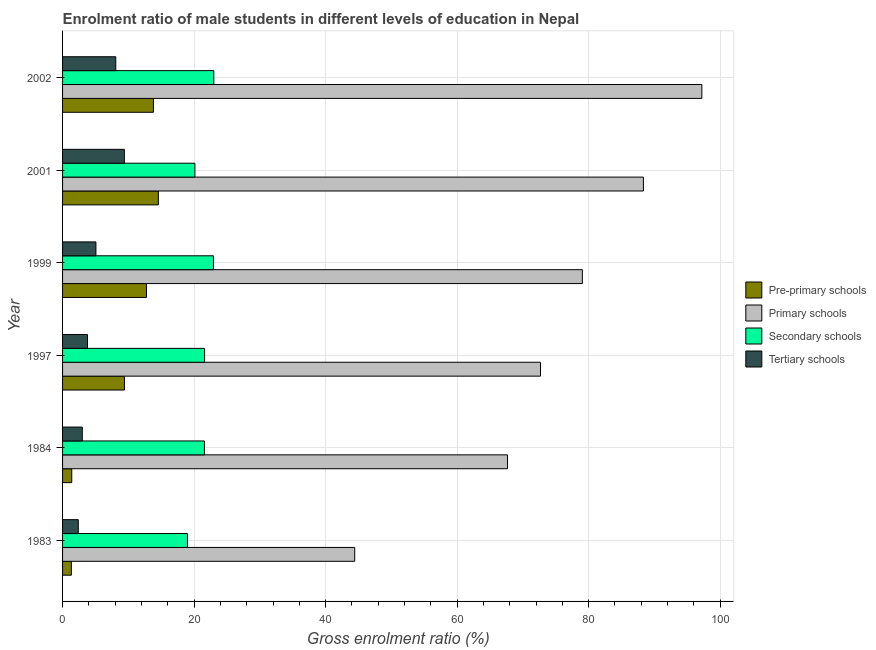How many different coloured bars are there?
Make the answer very short. 4. Are the number of bars on each tick of the Y-axis equal?
Ensure brevity in your answer.  Yes. How many bars are there on the 3rd tick from the top?
Offer a very short reply. 4. In how many cases, is the number of bars for a given year not equal to the number of legend labels?
Keep it short and to the point. 0. What is the gross enrolment ratio(female) in primary schools in 2001?
Give a very brief answer. 88.33. Across all years, what is the maximum gross enrolment ratio(female) in primary schools?
Ensure brevity in your answer.  97.22. Across all years, what is the minimum gross enrolment ratio(female) in pre-primary schools?
Provide a succinct answer. 1.33. In which year was the gross enrolment ratio(female) in pre-primary schools maximum?
Your response must be concise. 2001. What is the total gross enrolment ratio(female) in tertiary schools in the graph?
Offer a terse response. 31.73. What is the difference between the gross enrolment ratio(female) in pre-primary schools in 1997 and that in 2001?
Your answer should be very brief. -5.16. What is the difference between the gross enrolment ratio(female) in secondary schools in 2002 and the gross enrolment ratio(female) in pre-primary schools in 1983?
Keep it short and to the point. 21.67. What is the average gross enrolment ratio(female) in tertiary schools per year?
Keep it short and to the point. 5.29. In the year 2001, what is the difference between the gross enrolment ratio(female) in secondary schools and gross enrolment ratio(female) in primary schools?
Give a very brief answer. -68.2. What is the ratio of the gross enrolment ratio(female) in secondary schools in 1983 to that in 1999?
Your answer should be very brief. 0.83. What is the difference between the highest and the second highest gross enrolment ratio(female) in tertiary schools?
Offer a terse response. 1.3. What is the difference between the highest and the lowest gross enrolment ratio(female) in secondary schools?
Your response must be concise. 4.01. Is the sum of the gross enrolment ratio(female) in pre-primary schools in 1984 and 1997 greater than the maximum gross enrolment ratio(female) in tertiary schools across all years?
Your answer should be very brief. Yes. What does the 1st bar from the top in 1983 represents?
Ensure brevity in your answer.  Tertiary schools. What does the 1st bar from the bottom in 1997 represents?
Keep it short and to the point. Pre-primary schools. Are the values on the major ticks of X-axis written in scientific E-notation?
Offer a terse response. No. Does the graph contain any zero values?
Your answer should be very brief. No. What is the title of the graph?
Your answer should be compact. Enrolment ratio of male students in different levels of education in Nepal. What is the label or title of the X-axis?
Give a very brief answer. Gross enrolment ratio (%). What is the label or title of the Y-axis?
Give a very brief answer. Year. What is the Gross enrolment ratio (%) of Pre-primary schools in 1983?
Offer a very short reply. 1.33. What is the Gross enrolment ratio (%) of Primary schools in 1983?
Offer a very short reply. 44.42. What is the Gross enrolment ratio (%) in Secondary schools in 1983?
Provide a short and direct response. 18.99. What is the Gross enrolment ratio (%) of Tertiary schools in 1983?
Offer a very short reply. 2.39. What is the Gross enrolment ratio (%) of Pre-primary schools in 1984?
Your response must be concise. 1.4. What is the Gross enrolment ratio (%) of Primary schools in 1984?
Offer a terse response. 67.66. What is the Gross enrolment ratio (%) of Secondary schools in 1984?
Provide a succinct answer. 21.57. What is the Gross enrolment ratio (%) in Tertiary schools in 1984?
Offer a terse response. 3. What is the Gross enrolment ratio (%) in Pre-primary schools in 1997?
Give a very brief answer. 9.41. What is the Gross enrolment ratio (%) in Primary schools in 1997?
Offer a very short reply. 72.68. What is the Gross enrolment ratio (%) in Secondary schools in 1997?
Your response must be concise. 21.6. What is the Gross enrolment ratio (%) of Tertiary schools in 1997?
Your answer should be very brief. 3.79. What is the Gross enrolment ratio (%) of Pre-primary schools in 1999?
Offer a very short reply. 12.76. What is the Gross enrolment ratio (%) in Primary schools in 1999?
Your response must be concise. 79.04. What is the Gross enrolment ratio (%) in Secondary schools in 1999?
Offer a terse response. 22.95. What is the Gross enrolment ratio (%) in Tertiary schools in 1999?
Your answer should be compact. 5.07. What is the Gross enrolment ratio (%) of Pre-primary schools in 2001?
Your response must be concise. 14.57. What is the Gross enrolment ratio (%) of Primary schools in 2001?
Offer a very short reply. 88.33. What is the Gross enrolment ratio (%) in Secondary schools in 2001?
Ensure brevity in your answer.  20.13. What is the Gross enrolment ratio (%) of Tertiary schools in 2001?
Keep it short and to the point. 9.39. What is the Gross enrolment ratio (%) of Pre-primary schools in 2002?
Your answer should be very brief. 13.82. What is the Gross enrolment ratio (%) in Primary schools in 2002?
Provide a short and direct response. 97.22. What is the Gross enrolment ratio (%) in Secondary schools in 2002?
Make the answer very short. 23. What is the Gross enrolment ratio (%) in Tertiary schools in 2002?
Your answer should be compact. 8.09. Across all years, what is the maximum Gross enrolment ratio (%) in Pre-primary schools?
Ensure brevity in your answer.  14.57. Across all years, what is the maximum Gross enrolment ratio (%) of Primary schools?
Offer a very short reply. 97.22. Across all years, what is the maximum Gross enrolment ratio (%) in Secondary schools?
Your response must be concise. 23. Across all years, what is the maximum Gross enrolment ratio (%) in Tertiary schools?
Offer a terse response. 9.39. Across all years, what is the minimum Gross enrolment ratio (%) in Pre-primary schools?
Make the answer very short. 1.33. Across all years, what is the minimum Gross enrolment ratio (%) of Primary schools?
Keep it short and to the point. 44.42. Across all years, what is the minimum Gross enrolment ratio (%) of Secondary schools?
Your answer should be very brief. 18.99. Across all years, what is the minimum Gross enrolment ratio (%) of Tertiary schools?
Give a very brief answer. 2.39. What is the total Gross enrolment ratio (%) of Pre-primary schools in the graph?
Give a very brief answer. 53.29. What is the total Gross enrolment ratio (%) in Primary schools in the graph?
Ensure brevity in your answer.  449.36. What is the total Gross enrolment ratio (%) of Secondary schools in the graph?
Offer a very short reply. 128.24. What is the total Gross enrolment ratio (%) in Tertiary schools in the graph?
Offer a very short reply. 31.73. What is the difference between the Gross enrolment ratio (%) in Pre-primary schools in 1983 and that in 1984?
Make the answer very short. -0.06. What is the difference between the Gross enrolment ratio (%) in Primary schools in 1983 and that in 1984?
Make the answer very short. -23.24. What is the difference between the Gross enrolment ratio (%) in Secondary schools in 1983 and that in 1984?
Your response must be concise. -2.58. What is the difference between the Gross enrolment ratio (%) in Tertiary schools in 1983 and that in 1984?
Give a very brief answer. -0.61. What is the difference between the Gross enrolment ratio (%) in Pre-primary schools in 1983 and that in 1997?
Offer a very short reply. -8.07. What is the difference between the Gross enrolment ratio (%) in Primary schools in 1983 and that in 1997?
Your response must be concise. -28.25. What is the difference between the Gross enrolment ratio (%) in Secondary schools in 1983 and that in 1997?
Your answer should be compact. -2.6. What is the difference between the Gross enrolment ratio (%) of Tertiary schools in 1983 and that in 1997?
Offer a very short reply. -1.4. What is the difference between the Gross enrolment ratio (%) of Pre-primary schools in 1983 and that in 1999?
Provide a succinct answer. -11.43. What is the difference between the Gross enrolment ratio (%) of Primary schools in 1983 and that in 1999?
Your answer should be compact. -34.62. What is the difference between the Gross enrolment ratio (%) of Secondary schools in 1983 and that in 1999?
Make the answer very short. -3.96. What is the difference between the Gross enrolment ratio (%) in Tertiary schools in 1983 and that in 1999?
Offer a terse response. -2.68. What is the difference between the Gross enrolment ratio (%) in Pre-primary schools in 1983 and that in 2001?
Offer a terse response. -13.23. What is the difference between the Gross enrolment ratio (%) in Primary schools in 1983 and that in 2001?
Your answer should be very brief. -43.9. What is the difference between the Gross enrolment ratio (%) in Secondary schools in 1983 and that in 2001?
Your answer should be compact. -1.13. What is the difference between the Gross enrolment ratio (%) of Tertiary schools in 1983 and that in 2001?
Ensure brevity in your answer.  -7. What is the difference between the Gross enrolment ratio (%) in Pre-primary schools in 1983 and that in 2002?
Give a very brief answer. -12.49. What is the difference between the Gross enrolment ratio (%) in Primary schools in 1983 and that in 2002?
Your response must be concise. -52.79. What is the difference between the Gross enrolment ratio (%) in Secondary schools in 1983 and that in 2002?
Make the answer very short. -4.01. What is the difference between the Gross enrolment ratio (%) of Tertiary schools in 1983 and that in 2002?
Give a very brief answer. -5.7. What is the difference between the Gross enrolment ratio (%) in Pre-primary schools in 1984 and that in 1997?
Your response must be concise. -8.01. What is the difference between the Gross enrolment ratio (%) in Primary schools in 1984 and that in 1997?
Provide a short and direct response. -5.01. What is the difference between the Gross enrolment ratio (%) of Secondary schools in 1984 and that in 1997?
Provide a short and direct response. -0.03. What is the difference between the Gross enrolment ratio (%) of Tertiary schools in 1984 and that in 1997?
Offer a very short reply. -0.79. What is the difference between the Gross enrolment ratio (%) of Pre-primary schools in 1984 and that in 1999?
Ensure brevity in your answer.  -11.37. What is the difference between the Gross enrolment ratio (%) in Primary schools in 1984 and that in 1999?
Your answer should be very brief. -11.38. What is the difference between the Gross enrolment ratio (%) of Secondary schools in 1984 and that in 1999?
Ensure brevity in your answer.  -1.38. What is the difference between the Gross enrolment ratio (%) of Tertiary schools in 1984 and that in 1999?
Keep it short and to the point. -2.07. What is the difference between the Gross enrolment ratio (%) of Pre-primary schools in 1984 and that in 2001?
Offer a terse response. -13.17. What is the difference between the Gross enrolment ratio (%) of Primary schools in 1984 and that in 2001?
Keep it short and to the point. -20.66. What is the difference between the Gross enrolment ratio (%) in Secondary schools in 1984 and that in 2001?
Give a very brief answer. 1.45. What is the difference between the Gross enrolment ratio (%) in Tertiary schools in 1984 and that in 2001?
Give a very brief answer. -6.4. What is the difference between the Gross enrolment ratio (%) of Pre-primary schools in 1984 and that in 2002?
Give a very brief answer. -12.42. What is the difference between the Gross enrolment ratio (%) in Primary schools in 1984 and that in 2002?
Provide a short and direct response. -29.55. What is the difference between the Gross enrolment ratio (%) in Secondary schools in 1984 and that in 2002?
Your answer should be compact. -1.43. What is the difference between the Gross enrolment ratio (%) in Tertiary schools in 1984 and that in 2002?
Provide a short and direct response. -5.09. What is the difference between the Gross enrolment ratio (%) of Pre-primary schools in 1997 and that in 1999?
Make the answer very short. -3.36. What is the difference between the Gross enrolment ratio (%) in Primary schools in 1997 and that in 1999?
Make the answer very short. -6.37. What is the difference between the Gross enrolment ratio (%) of Secondary schools in 1997 and that in 1999?
Provide a short and direct response. -1.35. What is the difference between the Gross enrolment ratio (%) of Tertiary schools in 1997 and that in 1999?
Offer a terse response. -1.28. What is the difference between the Gross enrolment ratio (%) in Pre-primary schools in 1997 and that in 2001?
Make the answer very short. -5.16. What is the difference between the Gross enrolment ratio (%) in Primary schools in 1997 and that in 2001?
Make the answer very short. -15.65. What is the difference between the Gross enrolment ratio (%) in Secondary schools in 1997 and that in 2001?
Your answer should be compact. 1.47. What is the difference between the Gross enrolment ratio (%) in Tertiary schools in 1997 and that in 2001?
Provide a succinct answer. -5.61. What is the difference between the Gross enrolment ratio (%) of Pre-primary schools in 1997 and that in 2002?
Make the answer very short. -4.41. What is the difference between the Gross enrolment ratio (%) of Primary schools in 1997 and that in 2002?
Give a very brief answer. -24.54. What is the difference between the Gross enrolment ratio (%) in Secondary schools in 1997 and that in 2002?
Provide a short and direct response. -1.4. What is the difference between the Gross enrolment ratio (%) of Tertiary schools in 1997 and that in 2002?
Offer a terse response. -4.3. What is the difference between the Gross enrolment ratio (%) in Pre-primary schools in 1999 and that in 2001?
Ensure brevity in your answer.  -1.8. What is the difference between the Gross enrolment ratio (%) of Primary schools in 1999 and that in 2001?
Keep it short and to the point. -9.28. What is the difference between the Gross enrolment ratio (%) in Secondary schools in 1999 and that in 2001?
Offer a very short reply. 2.82. What is the difference between the Gross enrolment ratio (%) in Tertiary schools in 1999 and that in 2001?
Ensure brevity in your answer.  -4.32. What is the difference between the Gross enrolment ratio (%) of Pre-primary schools in 1999 and that in 2002?
Your answer should be compact. -1.06. What is the difference between the Gross enrolment ratio (%) in Primary schools in 1999 and that in 2002?
Offer a terse response. -18.17. What is the difference between the Gross enrolment ratio (%) of Secondary schools in 1999 and that in 2002?
Your answer should be very brief. -0.05. What is the difference between the Gross enrolment ratio (%) in Tertiary schools in 1999 and that in 2002?
Keep it short and to the point. -3.02. What is the difference between the Gross enrolment ratio (%) of Pre-primary schools in 2001 and that in 2002?
Offer a very short reply. 0.75. What is the difference between the Gross enrolment ratio (%) in Primary schools in 2001 and that in 2002?
Offer a terse response. -8.89. What is the difference between the Gross enrolment ratio (%) of Secondary schools in 2001 and that in 2002?
Your answer should be compact. -2.87. What is the difference between the Gross enrolment ratio (%) in Tertiary schools in 2001 and that in 2002?
Offer a terse response. 1.3. What is the difference between the Gross enrolment ratio (%) in Pre-primary schools in 1983 and the Gross enrolment ratio (%) in Primary schools in 1984?
Your response must be concise. -66.33. What is the difference between the Gross enrolment ratio (%) in Pre-primary schools in 1983 and the Gross enrolment ratio (%) in Secondary schools in 1984?
Keep it short and to the point. -20.24. What is the difference between the Gross enrolment ratio (%) in Pre-primary schools in 1983 and the Gross enrolment ratio (%) in Tertiary schools in 1984?
Give a very brief answer. -1.66. What is the difference between the Gross enrolment ratio (%) of Primary schools in 1983 and the Gross enrolment ratio (%) of Secondary schools in 1984?
Make the answer very short. 22.85. What is the difference between the Gross enrolment ratio (%) in Primary schools in 1983 and the Gross enrolment ratio (%) in Tertiary schools in 1984?
Provide a succinct answer. 41.43. What is the difference between the Gross enrolment ratio (%) of Secondary schools in 1983 and the Gross enrolment ratio (%) of Tertiary schools in 1984?
Your answer should be very brief. 15.99. What is the difference between the Gross enrolment ratio (%) in Pre-primary schools in 1983 and the Gross enrolment ratio (%) in Primary schools in 1997?
Make the answer very short. -71.34. What is the difference between the Gross enrolment ratio (%) in Pre-primary schools in 1983 and the Gross enrolment ratio (%) in Secondary schools in 1997?
Offer a very short reply. -20.26. What is the difference between the Gross enrolment ratio (%) in Pre-primary schools in 1983 and the Gross enrolment ratio (%) in Tertiary schools in 1997?
Your response must be concise. -2.45. What is the difference between the Gross enrolment ratio (%) of Primary schools in 1983 and the Gross enrolment ratio (%) of Secondary schools in 1997?
Make the answer very short. 22.83. What is the difference between the Gross enrolment ratio (%) in Primary schools in 1983 and the Gross enrolment ratio (%) in Tertiary schools in 1997?
Your answer should be compact. 40.64. What is the difference between the Gross enrolment ratio (%) of Secondary schools in 1983 and the Gross enrolment ratio (%) of Tertiary schools in 1997?
Offer a very short reply. 15.21. What is the difference between the Gross enrolment ratio (%) in Pre-primary schools in 1983 and the Gross enrolment ratio (%) in Primary schools in 1999?
Give a very brief answer. -77.71. What is the difference between the Gross enrolment ratio (%) in Pre-primary schools in 1983 and the Gross enrolment ratio (%) in Secondary schools in 1999?
Keep it short and to the point. -21.61. What is the difference between the Gross enrolment ratio (%) of Pre-primary schools in 1983 and the Gross enrolment ratio (%) of Tertiary schools in 1999?
Your answer should be very brief. -3.74. What is the difference between the Gross enrolment ratio (%) of Primary schools in 1983 and the Gross enrolment ratio (%) of Secondary schools in 1999?
Your answer should be very brief. 21.48. What is the difference between the Gross enrolment ratio (%) in Primary schools in 1983 and the Gross enrolment ratio (%) in Tertiary schools in 1999?
Offer a terse response. 39.35. What is the difference between the Gross enrolment ratio (%) in Secondary schools in 1983 and the Gross enrolment ratio (%) in Tertiary schools in 1999?
Keep it short and to the point. 13.92. What is the difference between the Gross enrolment ratio (%) in Pre-primary schools in 1983 and the Gross enrolment ratio (%) in Primary schools in 2001?
Ensure brevity in your answer.  -86.99. What is the difference between the Gross enrolment ratio (%) of Pre-primary schools in 1983 and the Gross enrolment ratio (%) of Secondary schools in 2001?
Offer a very short reply. -18.79. What is the difference between the Gross enrolment ratio (%) of Pre-primary schools in 1983 and the Gross enrolment ratio (%) of Tertiary schools in 2001?
Your response must be concise. -8.06. What is the difference between the Gross enrolment ratio (%) in Primary schools in 1983 and the Gross enrolment ratio (%) in Secondary schools in 2001?
Keep it short and to the point. 24.3. What is the difference between the Gross enrolment ratio (%) of Primary schools in 1983 and the Gross enrolment ratio (%) of Tertiary schools in 2001?
Your response must be concise. 35.03. What is the difference between the Gross enrolment ratio (%) in Secondary schools in 1983 and the Gross enrolment ratio (%) in Tertiary schools in 2001?
Give a very brief answer. 9.6. What is the difference between the Gross enrolment ratio (%) of Pre-primary schools in 1983 and the Gross enrolment ratio (%) of Primary schools in 2002?
Make the answer very short. -95.88. What is the difference between the Gross enrolment ratio (%) of Pre-primary schools in 1983 and the Gross enrolment ratio (%) of Secondary schools in 2002?
Ensure brevity in your answer.  -21.67. What is the difference between the Gross enrolment ratio (%) in Pre-primary schools in 1983 and the Gross enrolment ratio (%) in Tertiary schools in 2002?
Your answer should be very brief. -6.76. What is the difference between the Gross enrolment ratio (%) of Primary schools in 1983 and the Gross enrolment ratio (%) of Secondary schools in 2002?
Your answer should be very brief. 21.42. What is the difference between the Gross enrolment ratio (%) of Primary schools in 1983 and the Gross enrolment ratio (%) of Tertiary schools in 2002?
Offer a very short reply. 36.33. What is the difference between the Gross enrolment ratio (%) in Secondary schools in 1983 and the Gross enrolment ratio (%) in Tertiary schools in 2002?
Offer a terse response. 10.9. What is the difference between the Gross enrolment ratio (%) in Pre-primary schools in 1984 and the Gross enrolment ratio (%) in Primary schools in 1997?
Your answer should be compact. -71.28. What is the difference between the Gross enrolment ratio (%) in Pre-primary schools in 1984 and the Gross enrolment ratio (%) in Secondary schools in 1997?
Offer a terse response. -20.2. What is the difference between the Gross enrolment ratio (%) of Pre-primary schools in 1984 and the Gross enrolment ratio (%) of Tertiary schools in 1997?
Your answer should be compact. -2.39. What is the difference between the Gross enrolment ratio (%) of Primary schools in 1984 and the Gross enrolment ratio (%) of Secondary schools in 1997?
Provide a short and direct response. 46.07. What is the difference between the Gross enrolment ratio (%) of Primary schools in 1984 and the Gross enrolment ratio (%) of Tertiary schools in 1997?
Give a very brief answer. 63.88. What is the difference between the Gross enrolment ratio (%) in Secondary schools in 1984 and the Gross enrolment ratio (%) in Tertiary schools in 1997?
Your response must be concise. 17.78. What is the difference between the Gross enrolment ratio (%) of Pre-primary schools in 1984 and the Gross enrolment ratio (%) of Primary schools in 1999?
Your answer should be very brief. -77.65. What is the difference between the Gross enrolment ratio (%) of Pre-primary schools in 1984 and the Gross enrolment ratio (%) of Secondary schools in 1999?
Your answer should be very brief. -21.55. What is the difference between the Gross enrolment ratio (%) in Pre-primary schools in 1984 and the Gross enrolment ratio (%) in Tertiary schools in 1999?
Provide a succinct answer. -3.67. What is the difference between the Gross enrolment ratio (%) of Primary schools in 1984 and the Gross enrolment ratio (%) of Secondary schools in 1999?
Give a very brief answer. 44.71. What is the difference between the Gross enrolment ratio (%) in Primary schools in 1984 and the Gross enrolment ratio (%) in Tertiary schools in 1999?
Your answer should be very brief. 62.59. What is the difference between the Gross enrolment ratio (%) of Secondary schools in 1984 and the Gross enrolment ratio (%) of Tertiary schools in 1999?
Ensure brevity in your answer.  16.5. What is the difference between the Gross enrolment ratio (%) in Pre-primary schools in 1984 and the Gross enrolment ratio (%) in Primary schools in 2001?
Give a very brief answer. -86.93. What is the difference between the Gross enrolment ratio (%) in Pre-primary schools in 1984 and the Gross enrolment ratio (%) in Secondary schools in 2001?
Make the answer very short. -18.73. What is the difference between the Gross enrolment ratio (%) of Pre-primary schools in 1984 and the Gross enrolment ratio (%) of Tertiary schools in 2001?
Your answer should be compact. -8. What is the difference between the Gross enrolment ratio (%) of Primary schools in 1984 and the Gross enrolment ratio (%) of Secondary schools in 2001?
Provide a succinct answer. 47.54. What is the difference between the Gross enrolment ratio (%) of Primary schools in 1984 and the Gross enrolment ratio (%) of Tertiary schools in 2001?
Provide a succinct answer. 58.27. What is the difference between the Gross enrolment ratio (%) of Secondary schools in 1984 and the Gross enrolment ratio (%) of Tertiary schools in 2001?
Make the answer very short. 12.18. What is the difference between the Gross enrolment ratio (%) of Pre-primary schools in 1984 and the Gross enrolment ratio (%) of Primary schools in 2002?
Offer a very short reply. -95.82. What is the difference between the Gross enrolment ratio (%) in Pre-primary schools in 1984 and the Gross enrolment ratio (%) in Secondary schools in 2002?
Your answer should be compact. -21.6. What is the difference between the Gross enrolment ratio (%) of Pre-primary schools in 1984 and the Gross enrolment ratio (%) of Tertiary schools in 2002?
Your response must be concise. -6.69. What is the difference between the Gross enrolment ratio (%) of Primary schools in 1984 and the Gross enrolment ratio (%) of Secondary schools in 2002?
Ensure brevity in your answer.  44.66. What is the difference between the Gross enrolment ratio (%) of Primary schools in 1984 and the Gross enrolment ratio (%) of Tertiary schools in 2002?
Your response must be concise. 59.57. What is the difference between the Gross enrolment ratio (%) of Secondary schools in 1984 and the Gross enrolment ratio (%) of Tertiary schools in 2002?
Your answer should be very brief. 13.48. What is the difference between the Gross enrolment ratio (%) in Pre-primary schools in 1997 and the Gross enrolment ratio (%) in Primary schools in 1999?
Keep it short and to the point. -69.64. What is the difference between the Gross enrolment ratio (%) in Pre-primary schools in 1997 and the Gross enrolment ratio (%) in Secondary schools in 1999?
Offer a very short reply. -13.54. What is the difference between the Gross enrolment ratio (%) in Pre-primary schools in 1997 and the Gross enrolment ratio (%) in Tertiary schools in 1999?
Give a very brief answer. 4.34. What is the difference between the Gross enrolment ratio (%) of Primary schools in 1997 and the Gross enrolment ratio (%) of Secondary schools in 1999?
Provide a short and direct response. 49.73. What is the difference between the Gross enrolment ratio (%) in Primary schools in 1997 and the Gross enrolment ratio (%) in Tertiary schools in 1999?
Your response must be concise. 67.61. What is the difference between the Gross enrolment ratio (%) of Secondary schools in 1997 and the Gross enrolment ratio (%) of Tertiary schools in 1999?
Provide a succinct answer. 16.52. What is the difference between the Gross enrolment ratio (%) in Pre-primary schools in 1997 and the Gross enrolment ratio (%) in Primary schools in 2001?
Your answer should be compact. -78.92. What is the difference between the Gross enrolment ratio (%) of Pre-primary schools in 1997 and the Gross enrolment ratio (%) of Secondary schools in 2001?
Make the answer very short. -10.72. What is the difference between the Gross enrolment ratio (%) of Pre-primary schools in 1997 and the Gross enrolment ratio (%) of Tertiary schools in 2001?
Provide a short and direct response. 0.02. What is the difference between the Gross enrolment ratio (%) in Primary schools in 1997 and the Gross enrolment ratio (%) in Secondary schools in 2001?
Ensure brevity in your answer.  52.55. What is the difference between the Gross enrolment ratio (%) of Primary schools in 1997 and the Gross enrolment ratio (%) of Tertiary schools in 2001?
Make the answer very short. 63.28. What is the difference between the Gross enrolment ratio (%) of Secondary schools in 1997 and the Gross enrolment ratio (%) of Tertiary schools in 2001?
Keep it short and to the point. 12.2. What is the difference between the Gross enrolment ratio (%) in Pre-primary schools in 1997 and the Gross enrolment ratio (%) in Primary schools in 2002?
Provide a succinct answer. -87.81. What is the difference between the Gross enrolment ratio (%) of Pre-primary schools in 1997 and the Gross enrolment ratio (%) of Secondary schools in 2002?
Your answer should be very brief. -13.59. What is the difference between the Gross enrolment ratio (%) of Pre-primary schools in 1997 and the Gross enrolment ratio (%) of Tertiary schools in 2002?
Give a very brief answer. 1.32. What is the difference between the Gross enrolment ratio (%) in Primary schools in 1997 and the Gross enrolment ratio (%) in Secondary schools in 2002?
Your answer should be very brief. 49.68. What is the difference between the Gross enrolment ratio (%) of Primary schools in 1997 and the Gross enrolment ratio (%) of Tertiary schools in 2002?
Offer a terse response. 64.59. What is the difference between the Gross enrolment ratio (%) in Secondary schools in 1997 and the Gross enrolment ratio (%) in Tertiary schools in 2002?
Give a very brief answer. 13.51. What is the difference between the Gross enrolment ratio (%) of Pre-primary schools in 1999 and the Gross enrolment ratio (%) of Primary schools in 2001?
Your response must be concise. -75.56. What is the difference between the Gross enrolment ratio (%) of Pre-primary schools in 1999 and the Gross enrolment ratio (%) of Secondary schools in 2001?
Offer a very short reply. -7.36. What is the difference between the Gross enrolment ratio (%) in Pre-primary schools in 1999 and the Gross enrolment ratio (%) in Tertiary schools in 2001?
Provide a short and direct response. 3.37. What is the difference between the Gross enrolment ratio (%) in Primary schools in 1999 and the Gross enrolment ratio (%) in Secondary schools in 2001?
Keep it short and to the point. 58.92. What is the difference between the Gross enrolment ratio (%) of Primary schools in 1999 and the Gross enrolment ratio (%) of Tertiary schools in 2001?
Ensure brevity in your answer.  69.65. What is the difference between the Gross enrolment ratio (%) in Secondary schools in 1999 and the Gross enrolment ratio (%) in Tertiary schools in 2001?
Provide a short and direct response. 13.56. What is the difference between the Gross enrolment ratio (%) of Pre-primary schools in 1999 and the Gross enrolment ratio (%) of Primary schools in 2002?
Keep it short and to the point. -84.45. What is the difference between the Gross enrolment ratio (%) of Pre-primary schools in 1999 and the Gross enrolment ratio (%) of Secondary schools in 2002?
Offer a terse response. -10.23. What is the difference between the Gross enrolment ratio (%) of Pre-primary schools in 1999 and the Gross enrolment ratio (%) of Tertiary schools in 2002?
Give a very brief answer. 4.67. What is the difference between the Gross enrolment ratio (%) of Primary schools in 1999 and the Gross enrolment ratio (%) of Secondary schools in 2002?
Make the answer very short. 56.04. What is the difference between the Gross enrolment ratio (%) in Primary schools in 1999 and the Gross enrolment ratio (%) in Tertiary schools in 2002?
Make the answer very short. 70.95. What is the difference between the Gross enrolment ratio (%) of Secondary schools in 1999 and the Gross enrolment ratio (%) of Tertiary schools in 2002?
Provide a succinct answer. 14.86. What is the difference between the Gross enrolment ratio (%) of Pre-primary schools in 2001 and the Gross enrolment ratio (%) of Primary schools in 2002?
Give a very brief answer. -82.65. What is the difference between the Gross enrolment ratio (%) in Pre-primary schools in 2001 and the Gross enrolment ratio (%) in Secondary schools in 2002?
Your response must be concise. -8.43. What is the difference between the Gross enrolment ratio (%) in Pre-primary schools in 2001 and the Gross enrolment ratio (%) in Tertiary schools in 2002?
Provide a succinct answer. 6.48. What is the difference between the Gross enrolment ratio (%) of Primary schools in 2001 and the Gross enrolment ratio (%) of Secondary schools in 2002?
Offer a very short reply. 65.33. What is the difference between the Gross enrolment ratio (%) in Primary schools in 2001 and the Gross enrolment ratio (%) in Tertiary schools in 2002?
Your answer should be very brief. 80.24. What is the difference between the Gross enrolment ratio (%) of Secondary schools in 2001 and the Gross enrolment ratio (%) of Tertiary schools in 2002?
Your response must be concise. 12.03. What is the average Gross enrolment ratio (%) in Pre-primary schools per year?
Provide a succinct answer. 8.88. What is the average Gross enrolment ratio (%) of Primary schools per year?
Your answer should be very brief. 74.89. What is the average Gross enrolment ratio (%) in Secondary schools per year?
Your response must be concise. 21.37. What is the average Gross enrolment ratio (%) of Tertiary schools per year?
Offer a terse response. 5.29. In the year 1983, what is the difference between the Gross enrolment ratio (%) of Pre-primary schools and Gross enrolment ratio (%) of Primary schools?
Offer a very short reply. -43.09. In the year 1983, what is the difference between the Gross enrolment ratio (%) in Pre-primary schools and Gross enrolment ratio (%) in Secondary schools?
Ensure brevity in your answer.  -17.66. In the year 1983, what is the difference between the Gross enrolment ratio (%) in Pre-primary schools and Gross enrolment ratio (%) in Tertiary schools?
Provide a short and direct response. -1.06. In the year 1983, what is the difference between the Gross enrolment ratio (%) in Primary schools and Gross enrolment ratio (%) in Secondary schools?
Offer a very short reply. 25.43. In the year 1983, what is the difference between the Gross enrolment ratio (%) in Primary schools and Gross enrolment ratio (%) in Tertiary schools?
Provide a succinct answer. 42.03. In the year 1983, what is the difference between the Gross enrolment ratio (%) of Secondary schools and Gross enrolment ratio (%) of Tertiary schools?
Give a very brief answer. 16.6. In the year 1984, what is the difference between the Gross enrolment ratio (%) in Pre-primary schools and Gross enrolment ratio (%) in Primary schools?
Provide a succinct answer. -66.27. In the year 1984, what is the difference between the Gross enrolment ratio (%) in Pre-primary schools and Gross enrolment ratio (%) in Secondary schools?
Keep it short and to the point. -20.17. In the year 1984, what is the difference between the Gross enrolment ratio (%) of Pre-primary schools and Gross enrolment ratio (%) of Tertiary schools?
Ensure brevity in your answer.  -1.6. In the year 1984, what is the difference between the Gross enrolment ratio (%) in Primary schools and Gross enrolment ratio (%) in Secondary schools?
Offer a very short reply. 46.09. In the year 1984, what is the difference between the Gross enrolment ratio (%) of Primary schools and Gross enrolment ratio (%) of Tertiary schools?
Offer a terse response. 64.67. In the year 1984, what is the difference between the Gross enrolment ratio (%) in Secondary schools and Gross enrolment ratio (%) in Tertiary schools?
Offer a terse response. 18.57. In the year 1997, what is the difference between the Gross enrolment ratio (%) in Pre-primary schools and Gross enrolment ratio (%) in Primary schools?
Give a very brief answer. -63.27. In the year 1997, what is the difference between the Gross enrolment ratio (%) of Pre-primary schools and Gross enrolment ratio (%) of Secondary schools?
Offer a terse response. -12.19. In the year 1997, what is the difference between the Gross enrolment ratio (%) in Pre-primary schools and Gross enrolment ratio (%) in Tertiary schools?
Offer a very short reply. 5.62. In the year 1997, what is the difference between the Gross enrolment ratio (%) of Primary schools and Gross enrolment ratio (%) of Secondary schools?
Keep it short and to the point. 51.08. In the year 1997, what is the difference between the Gross enrolment ratio (%) in Primary schools and Gross enrolment ratio (%) in Tertiary schools?
Provide a succinct answer. 68.89. In the year 1997, what is the difference between the Gross enrolment ratio (%) in Secondary schools and Gross enrolment ratio (%) in Tertiary schools?
Give a very brief answer. 17.81. In the year 1999, what is the difference between the Gross enrolment ratio (%) in Pre-primary schools and Gross enrolment ratio (%) in Primary schools?
Your answer should be compact. -66.28. In the year 1999, what is the difference between the Gross enrolment ratio (%) of Pre-primary schools and Gross enrolment ratio (%) of Secondary schools?
Offer a very short reply. -10.18. In the year 1999, what is the difference between the Gross enrolment ratio (%) in Pre-primary schools and Gross enrolment ratio (%) in Tertiary schools?
Provide a short and direct response. 7.69. In the year 1999, what is the difference between the Gross enrolment ratio (%) in Primary schools and Gross enrolment ratio (%) in Secondary schools?
Ensure brevity in your answer.  56.1. In the year 1999, what is the difference between the Gross enrolment ratio (%) of Primary schools and Gross enrolment ratio (%) of Tertiary schools?
Ensure brevity in your answer.  73.97. In the year 1999, what is the difference between the Gross enrolment ratio (%) of Secondary schools and Gross enrolment ratio (%) of Tertiary schools?
Make the answer very short. 17.88. In the year 2001, what is the difference between the Gross enrolment ratio (%) in Pre-primary schools and Gross enrolment ratio (%) in Primary schools?
Provide a succinct answer. -73.76. In the year 2001, what is the difference between the Gross enrolment ratio (%) of Pre-primary schools and Gross enrolment ratio (%) of Secondary schools?
Provide a short and direct response. -5.56. In the year 2001, what is the difference between the Gross enrolment ratio (%) of Pre-primary schools and Gross enrolment ratio (%) of Tertiary schools?
Your answer should be very brief. 5.17. In the year 2001, what is the difference between the Gross enrolment ratio (%) in Primary schools and Gross enrolment ratio (%) in Secondary schools?
Ensure brevity in your answer.  68.2. In the year 2001, what is the difference between the Gross enrolment ratio (%) of Primary schools and Gross enrolment ratio (%) of Tertiary schools?
Give a very brief answer. 78.93. In the year 2001, what is the difference between the Gross enrolment ratio (%) in Secondary schools and Gross enrolment ratio (%) in Tertiary schools?
Provide a short and direct response. 10.73. In the year 2002, what is the difference between the Gross enrolment ratio (%) of Pre-primary schools and Gross enrolment ratio (%) of Primary schools?
Ensure brevity in your answer.  -83.39. In the year 2002, what is the difference between the Gross enrolment ratio (%) in Pre-primary schools and Gross enrolment ratio (%) in Secondary schools?
Your answer should be compact. -9.18. In the year 2002, what is the difference between the Gross enrolment ratio (%) of Pre-primary schools and Gross enrolment ratio (%) of Tertiary schools?
Your answer should be very brief. 5.73. In the year 2002, what is the difference between the Gross enrolment ratio (%) in Primary schools and Gross enrolment ratio (%) in Secondary schools?
Your answer should be very brief. 74.22. In the year 2002, what is the difference between the Gross enrolment ratio (%) of Primary schools and Gross enrolment ratio (%) of Tertiary schools?
Offer a terse response. 89.13. In the year 2002, what is the difference between the Gross enrolment ratio (%) of Secondary schools and Gross enrolment ratio (%) of Tertiary schools?
Provide a short and direct response. 14.91. What is the ratio of the Gross enrolment ratio (%) of Pre-primary schools in 1983 to that in 1984?
Provide a succinct answer. 0.96. What is the ratio of the Gross enrolment ratio (%) in Primary schools in 1983 to that in 1984?
Your answer should be very brief. 0.66. What is the ratio of the Gross enrolment ratio (%) in Secondary schools in 1983 to that in 1984?
Ensure brevity in your answer.  0.88. What is the ratio of the Gross enrolment ratio (%) of Tertiary schools in 1983 to that in 1984?
Offer a terse response. 0.8. What is the ratio of the Gross enrolment ratio (%) of Pre-primary schools in 1983 to that in 1997?
Provide a short and direct response. 0.14. What is the ratio of the Gross enrolment ratio (%) in Primary schools in 1983 to that in 1997?
Keep it short and to the point. 0.61. What is the ratio of the Gross enrolment ratio (%) of Secondary schools in 1983 to that in 1997?
Offer a terse response. 0.88. What is the ratio of the Gross enrolment ratio (%) in Tertiary schools in 1983 to that in 1997?
Provide a succinct answer. 0.63. What is the ratio of the Gross enrolment ratio (%) in Pre-primary schools in 1983 to that in 1999?
Your answer should be very brief. 0.1. What is the ratio of the Gross enrolment ratio (%) in Primary schools in 1983 to that in 1999?
Provide a succinct answer. 0.56. What is the ratio of the Gross enrolment ratio (%) in Secondary schools in 1983 to that in 1999?
Ensure brevity in your answer.  0.83. What is the ratio of the Gross enrolment ratio (%) in Tertiary schools in 1983 to that in 1999?
Your response must be concise. 0.47. What is the ratio of the Gross enrolment ratio (%) in Pre-primary schools in 1983 to that in 2001?
Provide a succinct answer. 0.09. What is the ratio of the Gross enrolment ratio (%) of Primary schools in 1983 to that in 2001?
Your answer should be very brief. 0.5. What is the ratio of the Gross enrolment ratio (%) in Secondary schools in 1983 to that in 2001?
Provide a short and direct response. 0.94. What is the ratio of the Gross enrolment ratio (%) of Tertiary schools in 1983 to that in 2001?
Your response must be concise. 0.25. What is the ratio of the Gross enrolment ratio (%) in Pre-primary schools in 1983 to that in 2002?
Make the answer very short. 0.1. What is the ratio of the Gross enrolment ratio (%) of Primary schools in 1983 to that in 2002?
Ensure brevity in your answer.  0.46. What is the ratio of the Gross enrolment ratio (%) in Secondary schools in 1983 to that in 2002?
Make the answer very short. 0.83. What is the ratio of the Gross enrolment ratio (%) in Tertiary schools in 1983 to that in 2002?
Your answer should be very brief. 0.3. What is the ratio of the Gross enrolment ratio (%) of Pre-primary schools in 1984 to that in 1997?
Your response must be concise. 0.15. What is the ratio of the Gross enrolment ratio (%) of Primary schools in 1984 to that in 1997?
Offer a terse response. 0.93. What is the ratio of the Gross enrolment ratio (%) in Tertiary schools in 1984 to that in 1997?
Give a very brief answer. 0.79. What is the ratio of the Gross enrolment ratio (%) of Pre-primary schools in 1984 to that in 1999?
Provide a short and direct response. 0.11. What is the ratio of the Gross enrolment ratio (%) of Primary schools in 1984 to that in 1999?
Your answer should be compact. 0.86. What is the ratio of the Gross enrolment ratio (%) of Tertiary schools in 1984 to that in 1999?
Offer a very short reply. 0.59. What is the ratio of the Gross enrolment ratio (%) of Pre-primary schools in 1984 to that in 2001?
Keep it short and to the point. 0.1. What is the ratio of the Gross enrolment ratio (%) in Primary schools in 1984 to that in 2001?
Make the answer very short. 0.77. What is the ratio of the Gross enrolment ratio (%) of Secondary schools in 1984 to that in 2001?
Offer a very short reply. 1.07. What is the ratio of the Gross enrolment ratio (%) in Tertiary schools in 1984 to that in 2001?
Offer a terse response. 0.32. What is the ratio of the Gross enrolment ratio (%) in Pre-primary schools in 1984 to that in 2002?
Make the answer very short. 0.1. What is the ratio of the Gross enrolment ratio (%) of Primary schools in 1984 to that in 2002?
Your response must be concise. 0.7. What is the ratio of the Gross enrolment ratio (%) in Secondary schools in 1984 to that in 2002?
Your answer should be very brief. 0.94. What is the ratio of the Gross enrolment ratio (%) in Tertiary schools in 1984 to that in 2002?
Offer a terse response. 0.37. What is the ratio of the Gross enrolment ratio (%) of Pre-primary schools in 1997 to that in 1999?
Provide a short and direct response. 0.74. What is the ratio of the Gross enrolment ratio (%) of Primary schools in 1997 to that in 1999?
Give a very brief answer. 0.92. What is the ratio of the Gross enrolment ratio (%) of Secondary schools in 1997 to that in 1999?
Your answer should be compact. 0.94. What is the ratio of the Gross enrolment ratio (%) of Tertiary schools in 1997 to that in 1999?
Provide a succinct answer. 0.75. What is the ratio of the Gross enrolment ratio (%) of Pre-primary schools in 1997 to that in 2001?
Give a very brief answer. 0.65. What is the ratio of the Gross enrolment ratio (%) of Primary schools in 1997 to that in 2001?
Ensure brevity in your answer.  0.82. What is the ratio of the Gross enrolment ratio (%) of Secondary schools in 1997 to that in 2001?
Ensure brevity in your answer.  1.07. What is the ratio of the Gross enrolment ratio (%) of Tertiary schools in 1997 to that in 2001?
Offer a very short reply. 0.4. What is the ratio of the Gross enrolment ratio (%) in Pre-primary schools in 1997 to that in 2002?
Keep it short and to the point. 0.68. What is the ratio of the Gross enrolment ratio (%) in Primary schools in 1997 to that in 2002?
Offer a very short reply. 0.75. What is the ratio of the Gross enrolment ratio (%) in Secondary schools in 1997 to that in 2002?
Your answer should be compact. 0.94. What is the ratio of the Gross enrolment ratio (%) of Tertiary schools in 1997 to that in 2002?
Your response must be concise. 0.47. What is the ratio of the Gross enrolment ratio (%) of Pre-primary schools in 1999 to that in 2001?
Make the answer very short. 0.88. What is the ratio of the Gross enrolment ratio (%) in Primary schools in 1999 to that in 2001?
Your response must be concise. 0.89. What is the ratio of the Gross enrolment ratio (%) of Secondary schools in 1999 to that in 2001?
Offer a terse response. 1.14. What is the ratio of the Gross enrolment ratio (%) of Tertiary schools in 1999 to that in 2001?
Offer a terse response. 0.54. What is the ratio of the Gross enrolment ratio (%) in Pre-primary schools in 1999 to that in 2002?
Your response must be concise. 0.92. What is the ratio of the Gross enrolment ratio (%) in Primary schools in 1999 to that in 2002?
Offer a terse response. 0.81. What is the ratio of the Gross enrolment ratio (%) in Tertiary schools in 1999 to that in 2002?
Offer a very short reply. 0.63. What is the ratio of the Gross enrolment ratio (%) in Pre-primary schools in 2001 to that in 2002?
Your response must be concise. 1.05. What is the ratio of the Gross enrolment ratio (%) in Primary schools in 2001 to that in 2002?
Your answer should be compact. 0.91. What is the ratio of the Gross enrolment ratio (%) of Tertiary schools in 2001 to that in 2002?
Your answer should be compact. 1.16. What is the difference between the highest and the second highest Gross enrolment ratio (%) of Pre-primary schools?
Your answer should be compact. 0.75. What is the difference between the highest and the second highest Gross enrolment ratio (%) in Primary schools?
Keep it short and to the point. 8.89. What is the difference between the highest and the second highest Gross enrolment ratio (%) in Secondary schools?
Your answer should be compact. 0.05. What is the difference between the highest and the second highest Gross enrolment ratio (%) in Tertiary schools?
Your answer should be compact. 1.3. What is the difference between the highest and the lowest Gross enrolment ratio (%) of Pre-primary schools?
Your response must be concise. 13.23. What is the difference between the highest and the lowest Gross enrolment ratio (%) in Primary schools?
Provide a succinct answer. 52.79. What is the difference between the highest and the lowest Gross enrolment ratio (%) in Secondary schools?
Offer a terse response. 4.01. What is the difference between the highest and the lowest Gross enrolment ratio (%) of Tertiary schools?
Your answer should be very brief. 7. 